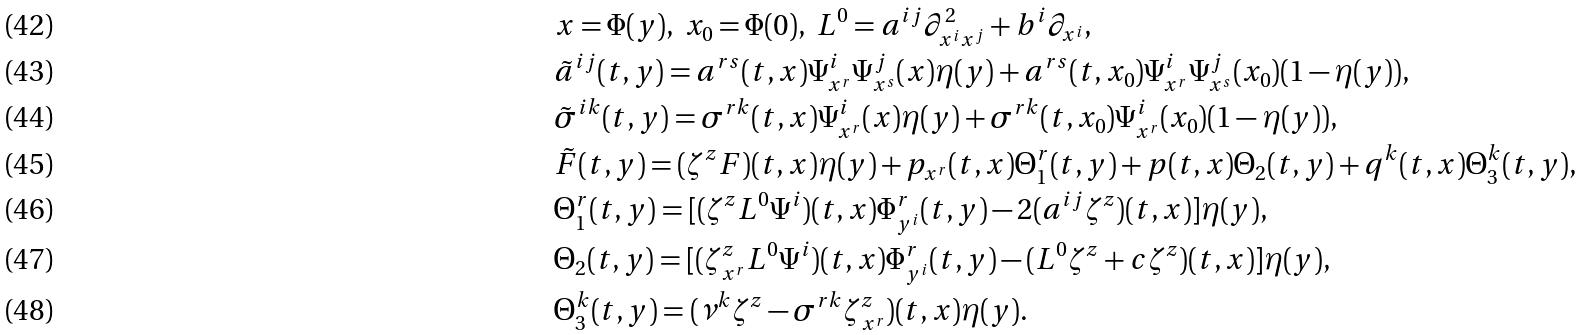<formula> <loc_0><loc_0><loc_500><loc_500>& x = \Phi ( y ) , \ x _ { 0 } = \Phi ( 0 ) , \ L ^ { 0 } = a ^ { i j } \partial ^ { 2 } _ { x ^ { i } x ^ { j } } + b ^ { i } \partial _ { x ^ { i } } , \\ & \tilde { a } ^ { i j } ( t , y ) = a ^ { r s } ( t , x ) \Psi ^ { i } _ { x ^ { r } } \Psi ^ { j } _ { x ^ { s } } ( x ) \eta ( y ) + a ^ { r s } ( t , x _ { 0 } ) \Psi ^ { i } _ { x ^ { r } } \Psi ^ { j } _ { x ^ { s } } ( x _ { 0 } ) ( 1 - \eta ( y ) ) , \\ & \tilde { \sigma } ^ { i k } ( t , y ) = \sigma ^ { r k } ( t , x ) \Psi ^ { i } _ { x ^ { r } } ( x ) \eta ( y ) + \sigma ^ { r k } ( t , x _ { 0 } ) \Psi ^ { i } _ { x ^ { r } } ( x _ { 0 } ) ( 1 - \eta ( y ) ) , \\ & \tilde { F } ( t , y ) = ( \zeta ^ { z } F ) ( t , x ) \eta ( y ) + p _ { x ^ { r } } ( t , x ) \Theta _ { 1 } ^ { r } ( t , y ) + p ( t , x ) \Theta _ { 2 } ( t , y ) + q ^ { k } ( t , x ) \Theta _ { 3 } ^ { k } ( t , y ) , \\ & \Theta _ { 1 } ^ { r } ( t , y ) = [ ( \zeta ^ { z } L ^ { 0 } \Psi ^ { i } ) ( t , x ) \Phi ^ { r } _ { y ^ { i } } ( t , y ) - 2 ( a ^ { i j } \zeta ^ { z } ) ( t , x ) ] \eta ( y ) , \\ & \Theta _ { 2 } ( t , y ) = [ ( \zeta ^ { z } _ { x ^ { r } } L ^ { 0 } \Psi ^ { i } ) ( t , x ) \Phi ^ { r } _ { y ^ { i } } ( t , y ) - ( L ^ { 0 } \zeta ^ { z } + c \zeta ^ { z } ) ( t , x ) ] \eta ( y ) , \\ & \Theta _ { 3 } ^ { k } ( t , y ) = ( \nu ^ { k } \zeta ^ { z } - \sigma ^ { r k } \zeta ^ { z } _ { x ^ { r } } ) ( t , x ) \eta ( y ) .</formula> 